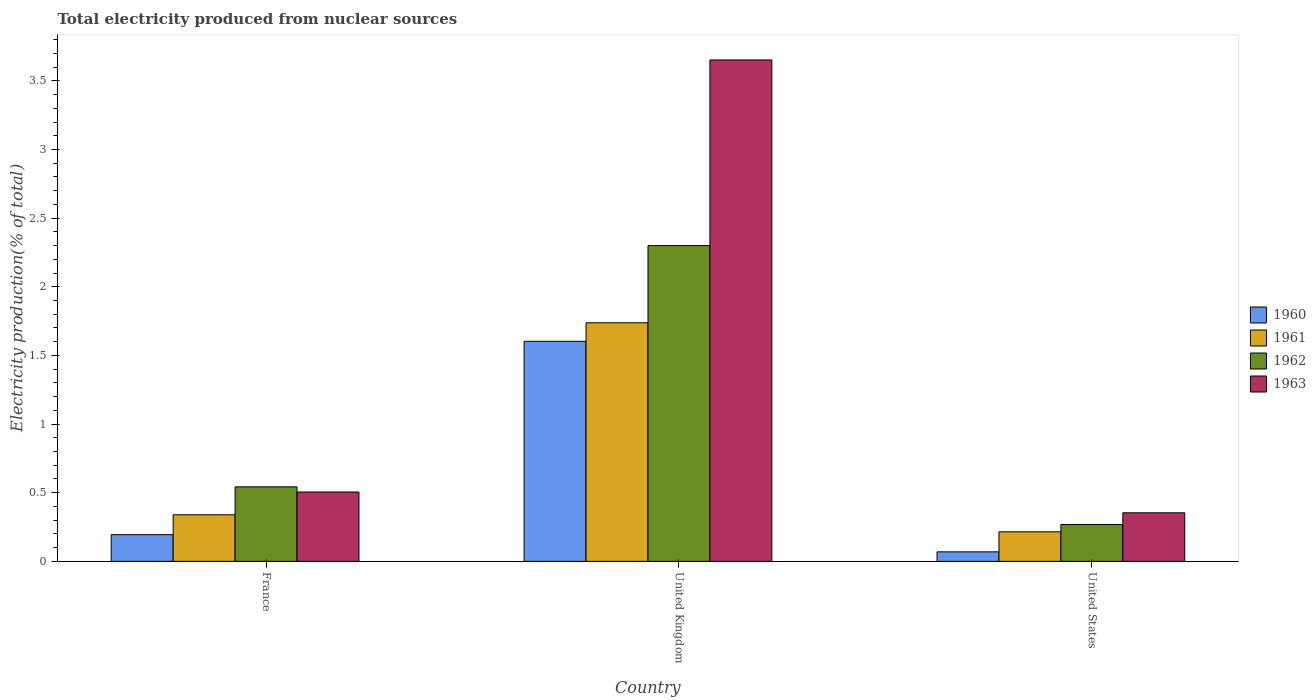How many different coloured bars are there?
Your answer should be compact. 4. How many groups of bars are there?
Your answer should be compact. 3. What is the total electricity produced in 1961 in United Kingdom?
Provide a succinct answer. 1.74. Across all countries, what is the maximum total electricity produced in 1960?
Your answer should be very brief. 1.6. Across all countries, what is the minimum total electricity produced in 1962?
Make the answer very short. 0.27. In which country was the total electricity produced in 1962 maximum?
Give a very brief answer. United Kingdom. In which country was the total electricity produced in 1961 minimum?
Give a very brief answer. United States. What is the total total electricity produced in 1963 in the graph?
Offer a very short reply. 4.51. What is the difference between the total electricity produced in 1962 in France and that in United States?
Keep it short and to the point. 0.27. What is the difference between the total electricity produced in 1962 in France and the total electricity produced in 1963 in United States?
Offer a very short reply. 0.19. What is the average total electricity produced in 1961 per country?
Provide a short and direct response. 0.76. What is the difference between the total electricity produced of/in 1962 and total electricity produced of/in 1961 in United Kingdom?
Ensure brevity in your answer.  0.56. What is the ratio of the total electricity produced in 1961 in France to that in United States?
Provide a succinct answer. 1.58. Is the difference between the total electricity produced in 1962 in France and United States greater than the difference between the total electricity produced in 1961 in France and United States?
Ensure brevity in your answer.  Yes. What is the difference between the highest and the second highest total electricity produced in 1963?
Provide a short and direct response. -3.15. What is the difference between the highest and the lowest total electricity produced in 1962?
Your response must be concise. 2.03. Is it the case that in every country, the sum of the total electricity produced in 1962 and total electricity produced in 1960 is greater than the sum of total electricity produced in 1963 and total electricity produced in 1961?
Your answer should be very brief. No. What does the 1st bar from the left in United Kingdom represents?
Your answer should be very brief. 1960. What does the 4th bar from the right in United States represents?
Your answer should be very brief. 1960. Is it the case that in every country, the sum of the total electricity produced in 1962 and total electricity produced in 1960 is greater than the total electricity produced in 1961?
Your response must be concise. Yes. How many bars are there?
Keep it short and to the point. 12. Are the values on the major ticks of Y-axis written in scientific E-notation?
Offer a very short reply. No. Does the graph contain any zero values?
Make the answer very short. No. Does the graph contain grids?
Your answer should be very brief. No. How many legend labels are there?
Provide a succinct answer. 4. How are the legend labels stacked?
Provide a succinct answer. Vertical. What is the title of the graph?
Offer a terse response. Total electricity produced from nuclear sources. Does "1960" appear as one of the legend labels in the graph?
Your answer should be very brief. Yes. What is the Electricity production(% of total) in 1960 in France?
Offer a very short reply. 0.19. What is the Electricity production(% of total) of 1961 in France?
Your response must be concise. 0.34. What is the Electricity production(% of total) in 1962 in France?
Ensure brevity in your answer.  0.54. What is the Electricity production(% of total) in 1963 in France?
Your answer should be very brief. 0.51. What is the Electricity production(% of total) of 1960 in United Kingdom?
Your answer should be compact. 1.6. What is the Electricity production(% of total) in 1961 in United Kingdom?
Your response must be concise. 1.74. What is the Electricity production(% of total) in 1962 in United Kingdom?
Provide a succinct answer. 2.3. What is the Electricity production(% of total) of 1963 in United Kingdom?
Your answer should be very brief. 3.65. What is the Electricity production(% of total) in 1960 in United States?
Ensure brevity in your answer.  0.07. What is the Electricity production(% of total) in 1961 in United States?
Your answer should be very brief. 0.22. What is the Electricity production(% of total) of 1962 in United States?
Offer a terse response. 0.27. What is the Electricity production(% of total) of 1963 in United States?
Make the answer very short. 0.35. Across all countries, what is the maximum Electricity production(% of total) in 1960?
Your response must be concise. 1.6. Across all countries, what is the maximum Electricity production(% of total) in 1961?
Provide a succinct answer. 1.74. Across all countries, what is the maximum Electricity production(% of total) in 1962?
Provide a succinct answer. 2.3. Across all countries, what is the maximum Electricity production(% of total) in 1963?
Provide a succinct answer. 3.65. Across all countries, what is the minimum Electricity production(% of total) in 1960?
Offer a terse response. 0.07. Across all countries, what is the minimum Electricity production(% of total) in 1961?
Ensure brevity in your answer.  0.22. Across all countries, what is the minimum Electricity production(% of total) in 1962?
Make the answer very short. 0.27. Across all countries, what is the minimum Electricity production(% of total) of 1963?
Provide a succinct answer. 0.35. What is the total Electricity production(% of total) of 1960 in the graph?
Your answer should be very brief. 1.87. What is the total Electricity production(% of total) of 1961 in the graph?
Offer a very short reply. 2.29. What is the total Electricity production(% of total) in 1962 in the graph?
Keep it short and to the point. 3.11. What is the total Electricity production(% of total) of 1963 in the graph?
Keep it short and to the point. 4.51. What is the difference between the Electricity production(% of total) of 1960 in France and that in United Kingdom?
Offer a terse response. -1.41. What is the difference between the Electricity production(% of total) of 1961 in France and that in United Kingdom?
Offer a very short reply. -1.4. What is the difference between the Electricity production(% of total) of 1962 in France and that in United Kingdom?
Keep it short and to the point. -1.76. What is the difference between the Electricity production(% of total) in 1963 in France and that in United Kingdom?
Offer a very short reply. -3.15. What is the difference between the Electricity production(% of total) of 1960 in France and that in United States?
Provide a short and direct response. 0.13. What is the difference between the Electricity production(% of total) in 1961 in France and that in United States?
Your response must be concise. 0.12. What is the difference between the Electricity production(% of total) of 1962 in France and that in United States?
Provide a succinct answer. 0.27. What is the difference between the Electricity production(% of total) of 1963 in France and that in United States?
Offer a terse response. 0.15. What is the difference between the Electricity production(% of total) in 1960 in United Kingdom and that in United States?
Provide a short and direct response. 1.53. What is the difference between the Electricity production(% of total) of 1961 in United Kingdom and that in United States?
Your answer should be compact. 1.52. What is the difference between the Electricity production(% of total) of 1962 in United Kingdom and that in United States?
Give a very brief answer. 2.03. What is the difference between the Electricity production(% of total) of 1963 in United Kingdom and that in United States?
Your answer should be very brief. 3.3. What is the difference between the Electricity production(% of total) of 1960 in France and the Electricity production(% of total) of 1961 in United Kingdom?
Offer a very short reply. -1.54. What is the difference between the Electricity production(% of total) in 1960 in France and the Electricity production(% of total) in 1962 in United Kingdom?
Provide a short and direct response. -2.11. What is the difference between the Electricity production(% of total) of 1960 in France and the Electricity production(% of total) of 1963 in United Kingdom?
Your response must be concise. -3.46. What is the difference between the Electricity production(% of total) of 1961 in France and the Electricity production(% of total) of 1962 in United Kingdom?
Your answer should be compact. -1.96. What is the difference between the Electricity production(% of total) in 1961 in France and the Electricity production(% of total) in 1963 in United Kingdom?
Keep it short and to the point. -3.31. What is the difference between the Electricity production(% of total) of 1962 in France and the Electricity production(% of total) of 1963 in United Kingdom?
Your response must be concise. -3.11. What is the difference between the Electricity production(% of total) in 1960 in France and the Electricity production(% of total) in 1961 in United States?
Offer a terse response. -0.02. What is the difference between the Electricity production(% of total) of 1960 in France and the Electricity production(% of total) of 1962 in United States?
Your answer should be very brief. -0.07. What is the difference between the Electricity production(% of total) of 1960 in France and the Electricity production(% of total) of 1963 in United States?
Provide a short and direct response. -0.16. What is the difference between the Electricity production(% of total) in 1961 in France and the Electricity production(% of total) in 1962 in United States?
Provide a succinct answer. 0.07. What is the difference between the Electricity production(% of total) of 1961 in France and the Electricity production(% of total) of 1963 in United States?
Provide a succinct answer. -0.01. What is the difference between the Electricity production(% of total) of 1962 in France and the Electricity production(% of total) of 1963 in United States?
Give a very brief answer. 0.19. What is the difference between the Electricity production(% of total) of 1960 in United Kingdom and the Electricity production(% of total) of 1961 in United States?
Keep it short and to the point. 1.39. What is the difference between the Electricity production(% of total) of 1960 in United Kingdom and the Electricity production(% of total) of 1962 in United States?
Give a very brief answer. 1.33. What is the difference between the Electricity production(% of total) of 1960 in United Kingdom and the Electricity production(% of total) of 1963 in United States?
Make the answer very short. 1.25. What is the difference between the Electricity production(% of total) of 1961 in United Kingdom and the Electricity production(% of total) of 1962 in United States?
Make the answer very short. 1.47. What is the difference between the Electricity production(% of total) of 1961 in United Kingdom and the Electricity production(% of total) of 1963 in United States?
Offer a terse response. 1.38. What is the difference between the Electricity production(% of total) in 1962 in United Kingdom and the Electricity production(% of total) in 1963 in United States?
Give a very brief answer. 1.95. What is the average Electricity production(% of total) of 1960 per country?
Ensure brevity in your answer.  0.62. What is the average Electricity production(% of total) of 1961 per country?
Offer a terse response. 0.76. What is the average Electricity production(% of total) in 1963 per country?
Give a very brief answer. 1.5. What is the difference between the Electricity production(% of total) of 1960 and Electricity production(% of total) of 1961 in France?
Your answer should be very brief. -0.14. What is the difference between the Electricity production(% of total) in 1960 and Electricity production(% of total) in 1962 in France?
Keep it short and to the point. -0.35. What is the difference between the Electricity production(% of total) in 1960 and Electricity production(% of total) in 1963 in France?
Offer a terse response. -0.31. What is the difference between the Electricity production(% of total) of 1961 and Electricity production(% of total) of 1962 in France?
Ensure brevity in your answer.  -0.2. What is the difference between the Electricity production(% of total) of 1961 and Electricity production(% of total) of 1963 in France?
Provide a short and direct response. -0.17. What is the difference between the Electricity production(% of total) of 1962 and Electricity production(% of total) of 1963 in France?
Your answer should be very brief. 0.04. What is the difference between the Electricity production(% of total) in 1960 and Electricity production(% of total) in 1961 in United Kingdom?
Your response must be concise. -0.13. What is the difference between the Electricity production(% of total) in 1960 and Electricity production(% of total) in 1962 in United Kingdom?
Ensure brevity in your answer.  -0.7. What is the difference between the Electricity production(% of total) in 1960 and Electricity production(% of total) in 1963 in United Kingdom?
Offer a very short reply. -2.05. What is the difference between the Electricity production(% of total) of 1961 and Electricity production(% of total) of 1962 in United Kingdom?
Ensure brevity in your answer.  -0.56. What is the difference between the Electricity production(% of total) of 1961 and Electricity production(% of total) of 1963 in United Kingdom?
Offer a terse response. -1.91. What is the difference between the Electricity production(% of total) of 1962 and Electricity production(% of total) of 1963 in United Kingdom?
Your response must be concise. -1.35. What is the difference between the Electricity production(% of total) in 1960 and Electricity production(% of total) in 1961 in United States?
Your answer should be compact. -0.15. What is the difference between the Electricity production(% of total) in 1960 and Electricity production(% of total) in 1962 in United States?
Your answer should be very brief. -0.2. What is the difference between the Electricity production(% of total) in 1960 and Electricity production(% of total) in 1963 in United States?
Provide a short and direct response. -0.28. What is the difference between the Electricity production(% of total) of 1961 and Electricity production(% of total) of 1962 in United States?
Offer a terse response. -0.05. What is the difference between the Electricity production(% of total) of 1961 and Electricity production(% of total) of 1963 in United States?
Your response must be concise. -0.14. What is the difference between the Electricity production(% of total) in 1962 and Electricity production(% of total) in 1963 in United States?
Provide a short and direct response. -0.09. What is the ratio of the Electricity production(% of total) of 1960 in France to that in United Kingdom?
Provide a short and direct response. 0.12. What is the ratio of the Electricity production(% of total) of 1961 in France to that in United Kingdom?
Your answer should be compact. 0.2. What is the ratio of the Electricity production(% of total) in 1962 in France to that in United Kingdom?
Provide a short and direct response. 0.24. What is the ratio of the Electricity production(% of total) in 1963 in France to that in United Kingdom?
Your answer should be compact. 0.14. What is the ratio of the Electricity production(% of total) in 1960 in France to that in United States?
Your answer should be compact. 2.81. What is the ratio of the Electricity production(% of total) in 1961 in France to that in United States?
Offer a very short reply. 1.58. What is the ratio of the Electricity production(% of total) in 1962 in France to that in United States?
Offer a very short reply. 2.02. What is the ratio of the Electricity production(% of total) in 1963 in France to that in United States?
Provide a succinct answer. 1.43. What is the ratio of the Electricity production(% of total) of 1960 in United Kingdom to that in United States?
Ensure brevity in your answer.  23.14. What is the ratio of the Electricity production(% of total) in 1961 in United Kingdom to that in United States?
Offer a terse response. 8.08. What is the ratio of the Electricity production(% of total) of 1962 in United Kingdom to that in United States?
Provide a short and direct response. 8.56. What is the ratio of the Electricity production(% of total) of 1963 in United Kingdom to that in United States?
Provide a short and direct response. 10.32. What is the difference between the highest and the second highest Electricity production(% of total) of 1960?
Provide a short and direct response. 1.41. What is the difference between the highest and the second highest Electricity production(% of total) in 1961?
Offer a terse response. 1.4. What is the difference between the highest and the second highest Electricity production(% of total) in 1962?
Make the answer very short. 1.76. What is the difference between the highest and the second highest Electricity production(% of total) of 1963?
Ensure brevity in your answer.  3.15. What is the difference between the highest and the lowest Electricity production(% of total) in 1960?
Give a very brief answer. 1.53. What is the difference between the highest and the lowest Electricity production(% of total) in 1961?
Your answer should be very brief. 1.52. What is the difference between the highest and the lowest Electricity production(% of total) in 1962?
Offer a very short reply. 2.03. What is the difference between the highest and the lowest Electricity production(% of total) of 1963?
Give a very brief answer. 3.3. 